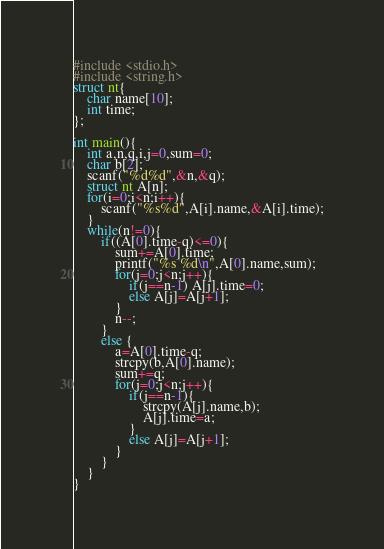Convert code to text. <code><loc_0><loc_0><loc_500><loc_500><_C_>#include <stdio.h>
#include <string.h>
struct nt{
    char name[10];
    int time;
};

int main(){
    int a,n,q,i,j=0,sum=0;
    char b[2];
    scanf("%d%d",&n,&q);
    struct nt A[n];
    for(i=0;i<n;i++){
        scanf("%s%d",A[i].name,&A[i].time);
    }
    while(n!=0){
        if((A[0].time-q)<=0){
            sum+=A[0].time;
            printf("%s %d\n",A[0].name,sum);
            for(j=0;j<n;j++){
                if(j==n-1) A[j].time=0;
                else A[j]=A[j+1];
            }
            n--;
        }
        else {
            a=A[0].time-q;
            strcpy(b,A[0].name);
            sum+=q;
            for(j=0;j<n;j++){
                if(j==n-1){
                    strcpy(A[j].name,b);
                    A[j].time=a;
                }
                else A[j]=A[j+1];
            }
        }
    }
}
</code> 